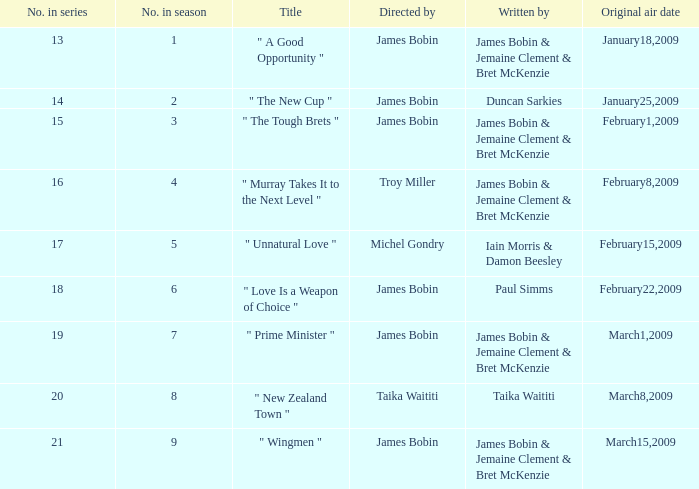When was the episode authored by iain morris and damon beesley first broadcasted? February15,2009. 